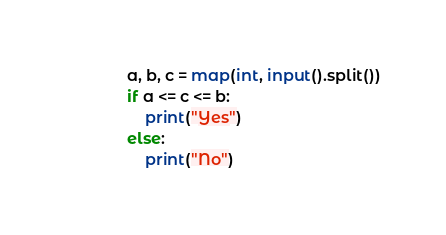Convert code to text. <code><loc_0><loc_0><loc_500><loc_500><_Python_>a, b, c = map(int, input().split())
if a <= c <= b:
    print("Yes")
else:
    print("No")</code> 